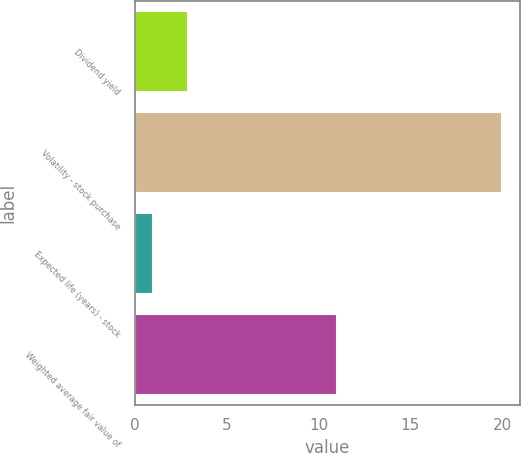Convert chart to OTSL. <chart><loc_0><loc_0><loc_500><loc_500><bar_chart><fcel>Dividend yield<fcel>Volatility - stock purchase<fcel>Expected life (years) - stock<fcel>Weighted average fair value of<nl><fcel>2.9<fcel>20<fcel>1<fcel>10.99<nl></chart> 